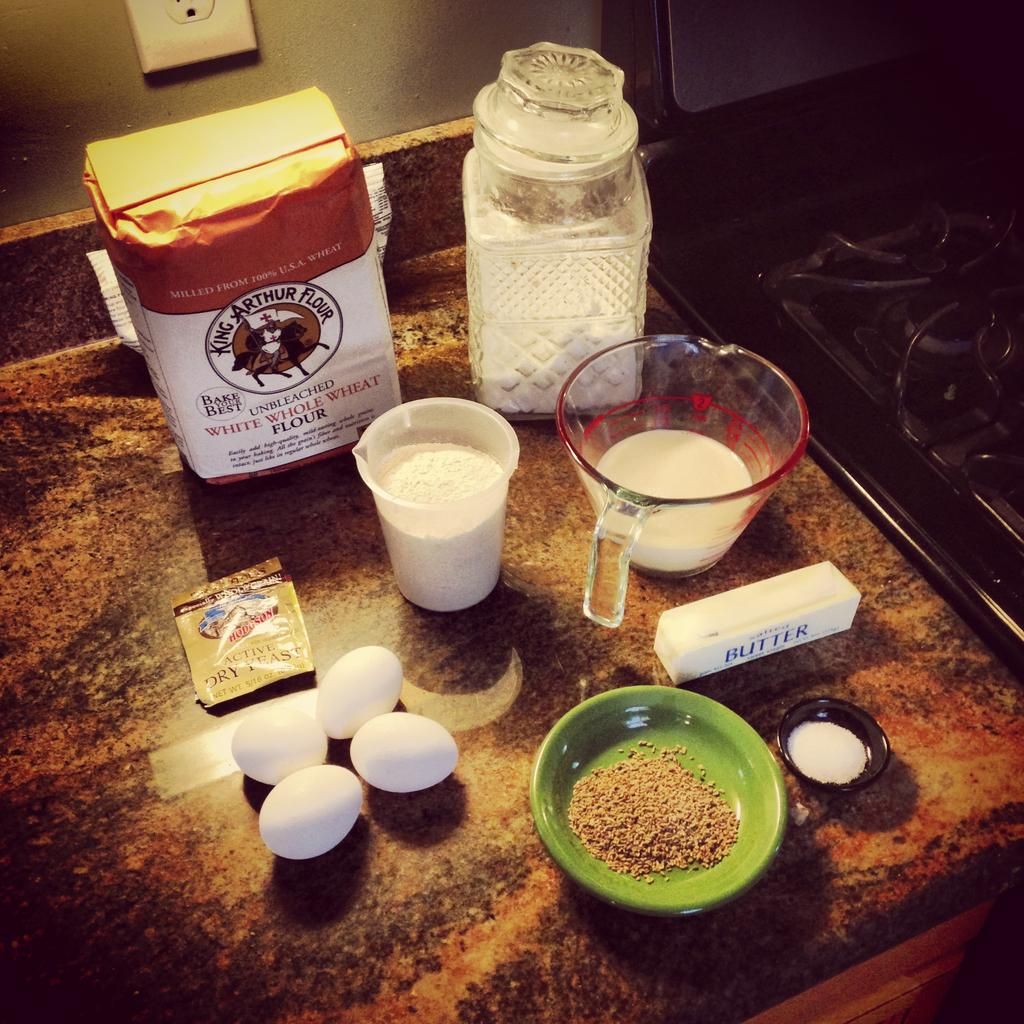What type of containers are present in the image? There are bowls and glasses in the image. What type of food item can be seen in the image? There are eggs in the image. What is the color of the surface in the image? The surface in the image is brown. What is the color of the wall in the background of the image? The wall in the background of the image is gray. What type of bed can be seen in the image? There is no bed present in the image. What type of operation is being performed in the image? There is no operation or any indication of a medical procedure in the image. 